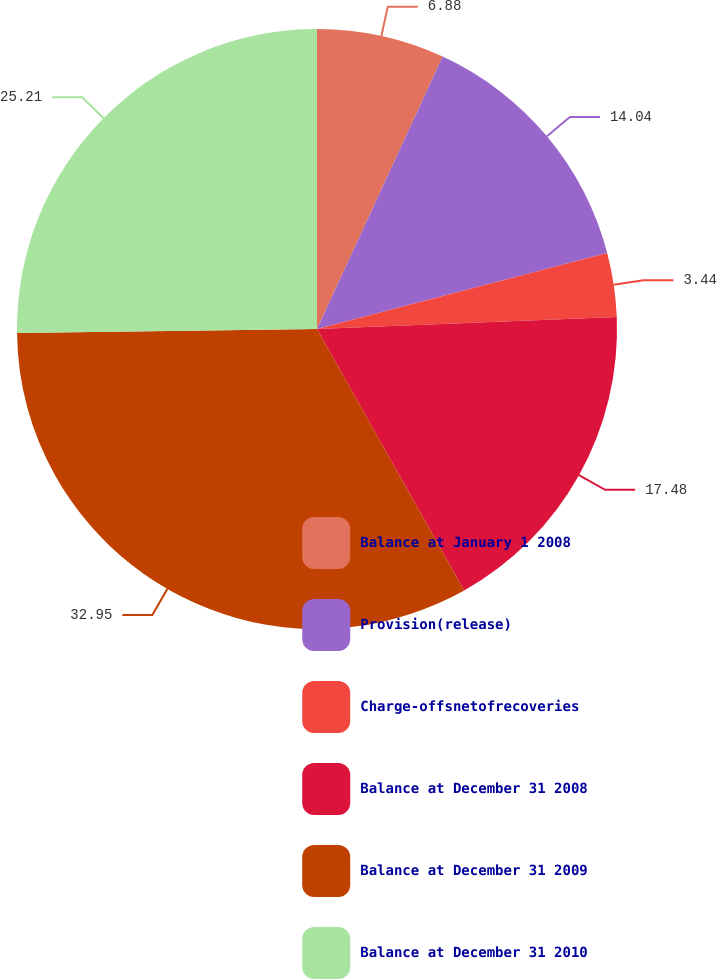Convert chart. <chart><loc_0><loc_0><loc_500><loc_500><pie_chart><fcel>Balance at January 1 2008<fcel>Provision(release)<fcel>Charge-offsnetofrecoveries<fcel>Balance at December 31 2008<fcel>Balance at December 31 2009<fcel>Balance at December 31 2010<nl><fcel>6.88%<fcel>14.04%<fcel>3.44%<fcel>17.48%<fcel>32.95%<fcel>25.21%<nl></chart> 